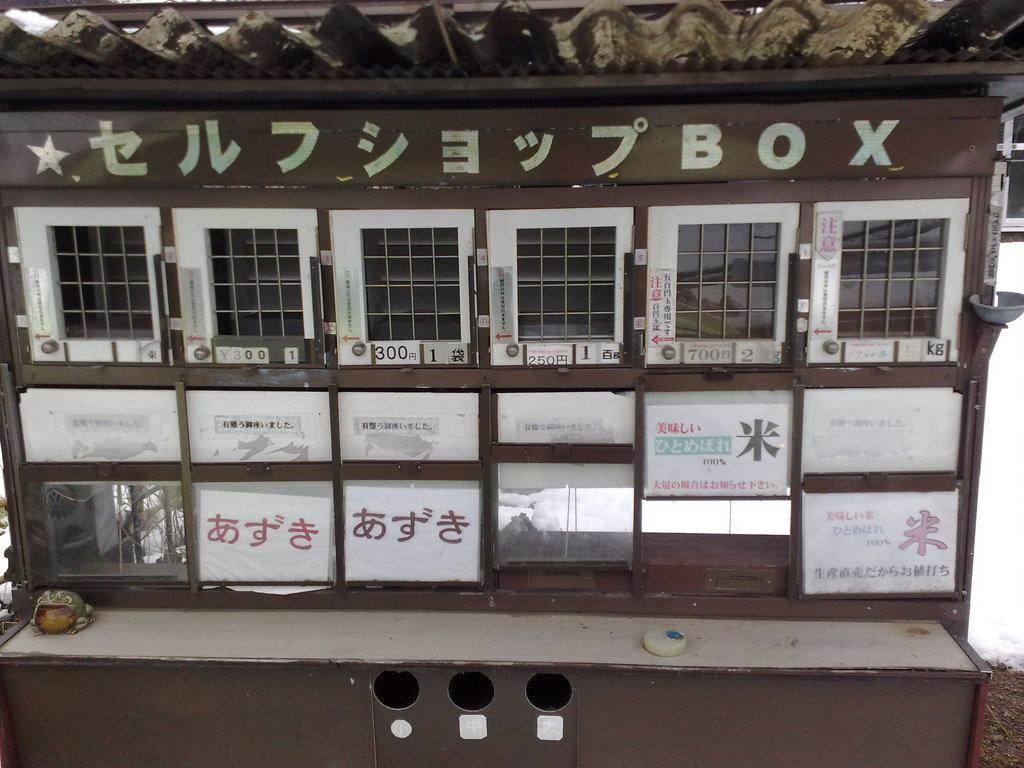<image>
Create a compact narrative representing the image presented. Several metal boxes on a wooden structure in Japan. 